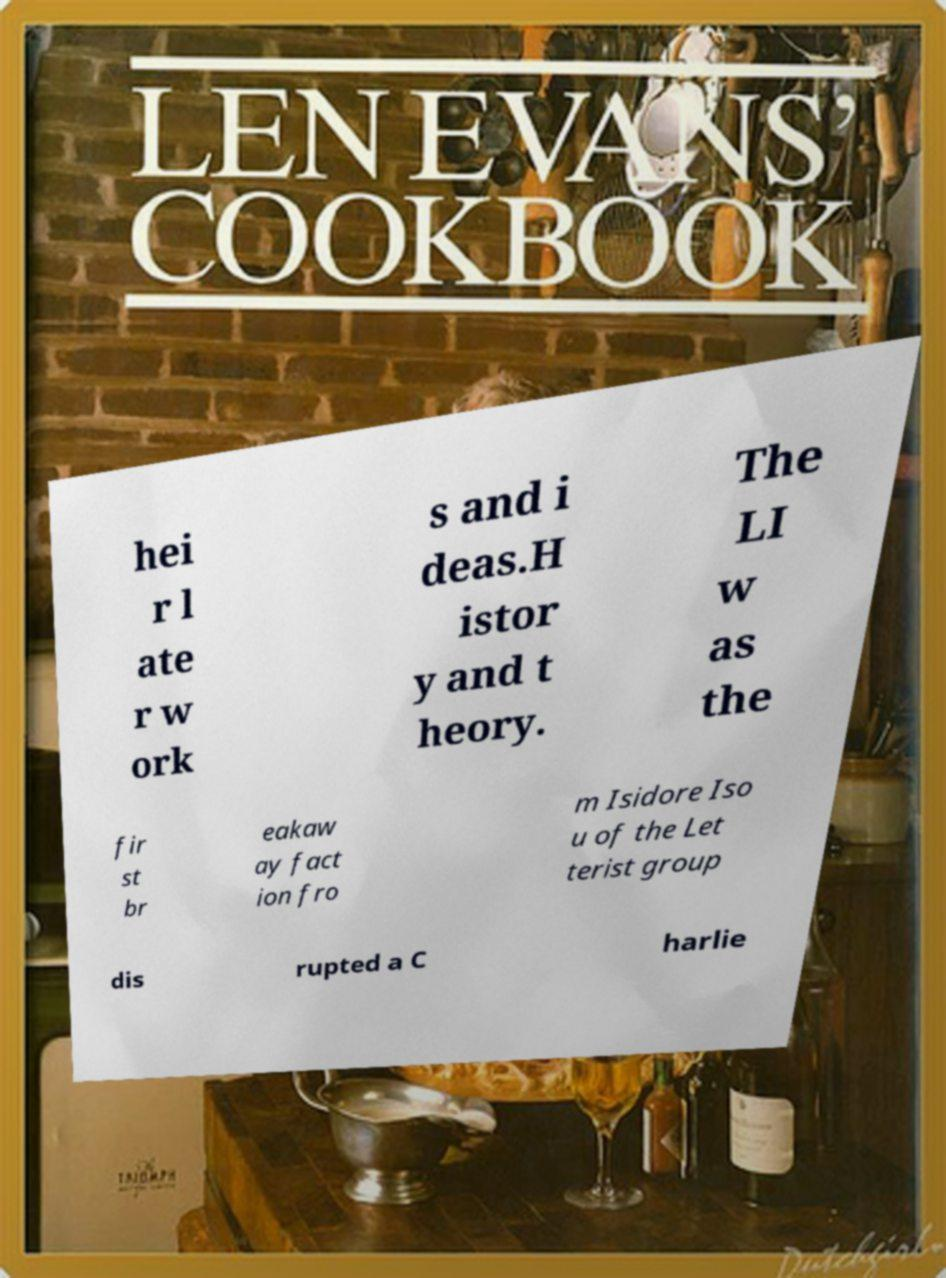There's text embedded in this image that I need extracted. Can you transcribe it verbatim? hei r l ate r w ork s and i deas.H istor y and t heory. The LI w as the fir st br eakaw ay fact ion fro m Isidore Iso u of the Let terist group dis rupted a C harlie 